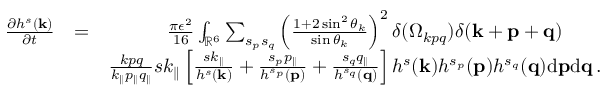Convert formula to latex. <formula><loc_0><loc_0><loc_500><loc_500>\begin{array} { r l r } { \frac { \partial h ^ { s } ( { k } ) } { \partial t } } & { = } & { \frac { \pi \epsilon ^ { 2 } } { 1 6 } \int _ { { \mathbb { R } } ^ { 6 } } \sum _ { s _ { p } s _ { q } } \left ( \frac { 1 + 2 \sin ^ { 2 } \theta _ { k } } { \sin \theta _ { k } } \right ) ^ { 2 } \delta ( \Omega _ { k p q } ) \delta ( { k } + { p } + { q } ) \quad } \\ & { \frac { k p q } { k _ { \| } p _ { \| } q _ { \| } } s k _ { \| } \left [ \frac { s k _ { \| } } { h ^ { s } ( { k } ) } + \frac { s _ { p } p _ { \| } } { h ^ { s _ { p } } ( { p } ) } + \frac { s _ { q } q _ { \| } } { h ^ { s _ { q } } ( { q } ) } \right ] h ^ { s } ( { k } ) h ^ { s _ { p } } ( { p } ) h ^ { s _ { q } } ( { q } ) d { p } d { q } \, . } \end{array}</formula> 